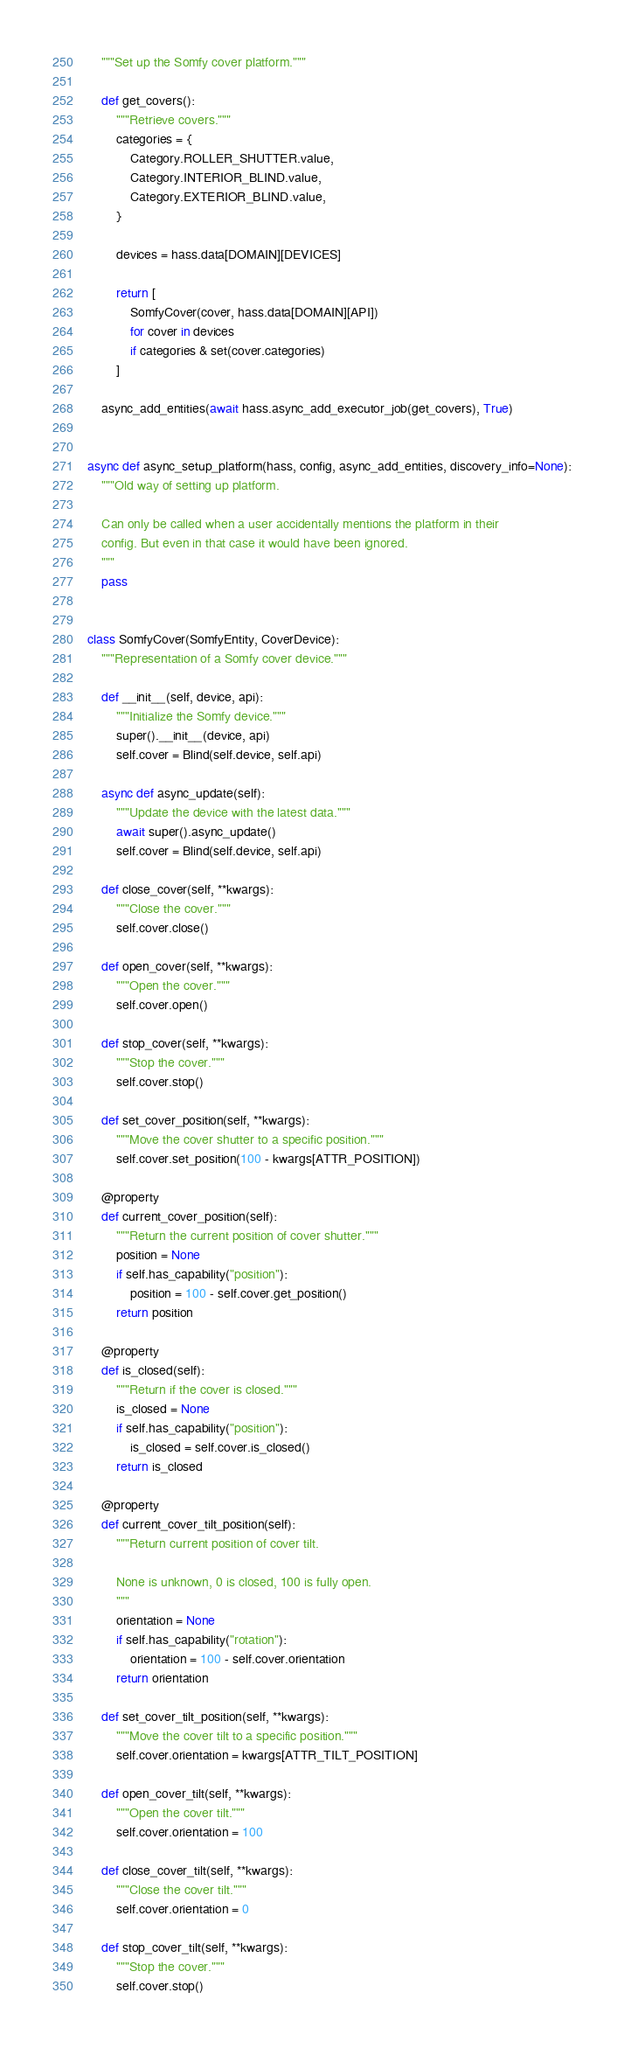<code> <loc_0><loc_0><loc_500><loc_500><_Python_>    """Set up the Somfy cover platform."""

    def get_covers():
        """Retrieve covers."""
        categories = {
            Category.ROLLER_SHUTTER.value,
            Category.INTERIOR_BLIND.value,
            Category.EXTERIOR_BLIND.value,
        }

        devices = hass.data[DOMAIN][DEVICES]

        return [
            SomfyCover(cover, hass.data[DOMAIN][API])
            for cover in devices
            if categories & set(cover.categories)
        ]

    async_add_entities(await hass.async_add_executor_job(get_covers), True)


async def async_setup_platform(hass, config, async_add_entities, discovery_info=None):
    """Old way of setting up platform.

    Can only be called when a user accidentally mentions the platform in their
    config. But even in that case it would have been ignored.
    """
    pass


class SomfyCover(SomfyEntity, CoverDevice):
    """Representation of a Somfy cover device."""

    def __init__(self, device, api):
        """Initialize the Somfy device."""
        super().__init__(device, api)
        self.cover = Blind(self.device, self.api)

    async def async_update(self):
        """Update the device with the latest data."""
        await super().async_update()
        self.cover = Blind(self.device, self.api)

    def close_cover(self, **kwargs):
        """Close the cover."""
        self.cover.close()

    def open_cover(self, **kwargs):
        """Open the cover."""
        self.cover.open()

    def stop_cover(self, **kwargs):
        """Stop the cover."""
        self.cover.stop()

    def set_cover_position(self, **kwargs):
        """Move the cover shutter to a specific position."""
        self.cover.set_position(100 - kwargs[ATTR_POSITION])

    @property
    def current_cover_position(self):
        """Return the current position of cover shutter."""
        position = None
        if self.has_capability("position"):
            position = 100 - self.cover.get_position()
        return position

    @property
    def is_closed(self):
        """Return if the cover is closed."""
        is_closed = None
        if self.has_capability("position"):
            is_closed = self.cover.is_closed()
        return is_closed

    @property
    def current_cover_tilt_position(self):
        """Return current position of cover tilt.

        None is unknown, 0 is closed, 100 is fully open.
        """
        orientation = None
        if self.has_capability("rotation"):
            orientation = 100 - self.cover.orientation
        return orientation

    def set_cover_tilt_position(self, **kwargs):
        """Move the cover tilt to a specific position."""
        self.cover.orientation = kwargs[ATTR_TILT_POSITION]

    def open_cover_tilt(self, **kwargs):
        """Open the cover tilt."""
        self.cover.orientation = 100

    def close_cover_tilt(self, **kwargs):
        """Close the cover tilt."""
        self.cover.orientation = 0

    def stop_cover_tilt(self, **kwargs):
        """Stop the cover."""
        self.cover.stop()
</code> 